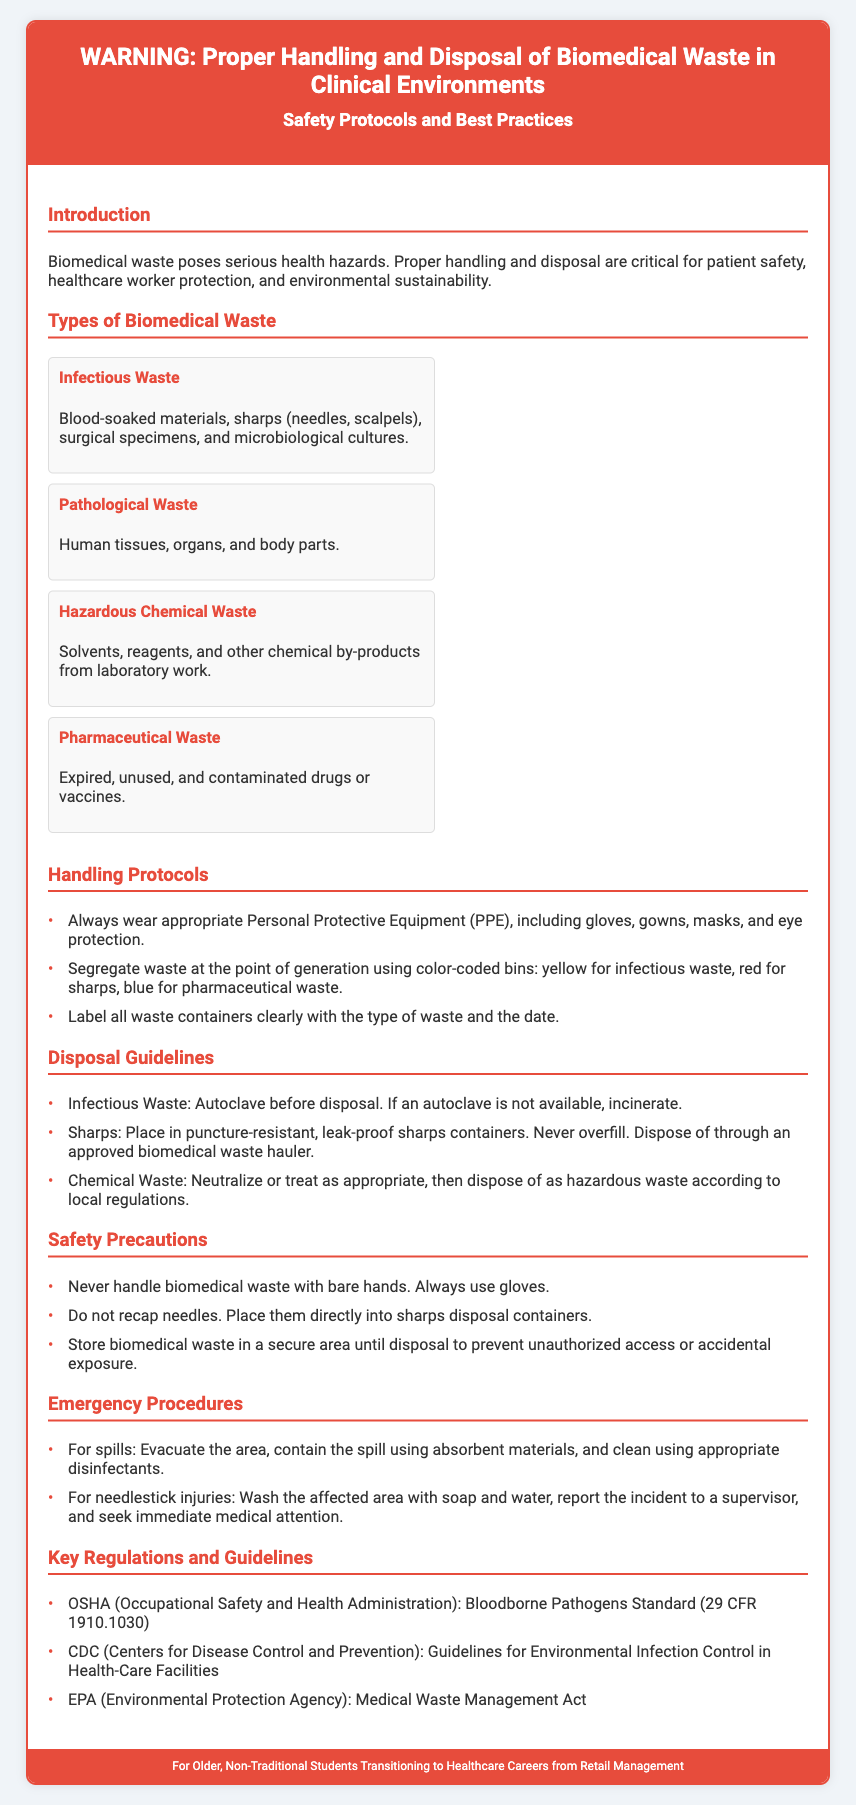What is the title of the document? The title of the document is provided in the header section and indicates the subject matter.
Answer: WARNING: Proper Handling and Disposal of Biomedical Waste in Clinical Environments What does PPE stand for? Personal Protective Equipment is mentioned as essential for handling biomedical waste safely.
Answer: Personal Protective Equipment What color is used for sharps waste containers? The document specifies color-coded bins for different types of biomedical waste, indicating the color for sharps waste.
Answer: Red What type of waste should be autoclaved before disposal? The disposal guidelines specifically mention a treatment method for infectious waste.
Answer: Infectious Waste What should be done in case of a needlestick injury? The emergency procedures section outlines the necessary steps to take after such an incident.
Answer: Wash the affected area with soap and water List one key regulation mentioned in the document. The list of key regulations provides guidelines for handling biomedical waste, including specific organizations and standards.
Answer: OSHA Explain how hazardous chemical waste should be treated before disposal. The disposal guidelines provide a clear procedure for handling hazardous chemical waste, indicating the treatment needed before its disposal.
Answer: Neutralize or treat as appropriate Which type of waste includes human tissues? This type of waste is clearly categorized in the types of biomedical waste section of the document.
Answer: Pathological Waste What is one key safety precaution when handling biomedical waste? This information is outlined in the safety precautions section, indicating important practices to ensure safety.
Answer: Never handle biomedical waste with bare hands 